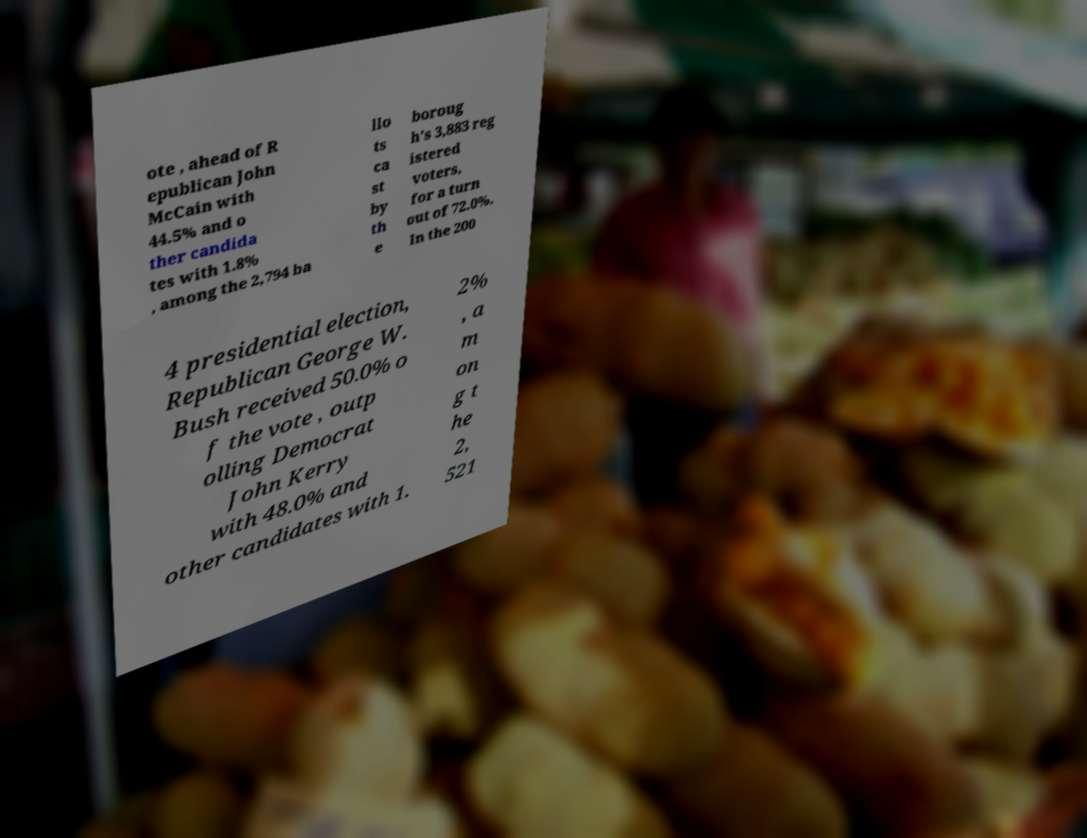Please identify and transcribe the text found in this image. ote , ahead of R epublican John McCain with 44.5% and o ther candida tes with 1.8% , among the 2,794 ba llo ts ca st by th e boroug h's 3,883 reg istered voters, for a turn out of 72.0%. In the 200 4 presidential election, Republican George W. Bush received 50.0% o f the vote , outp olling Democrat John Kerry with 48.0% and other candidates with 1. 2% , a m on g t he 2, 521 